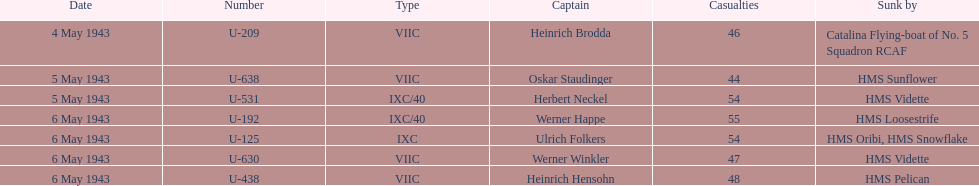How many captains are listed? 7. 